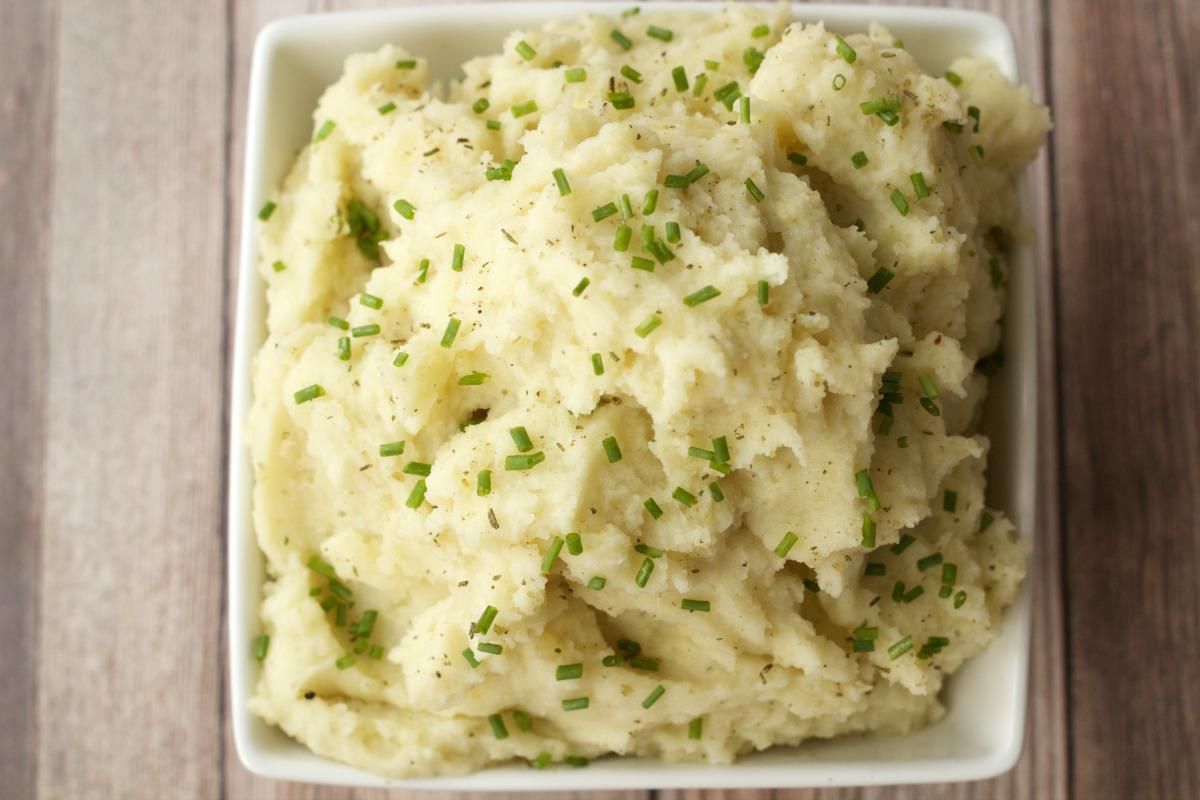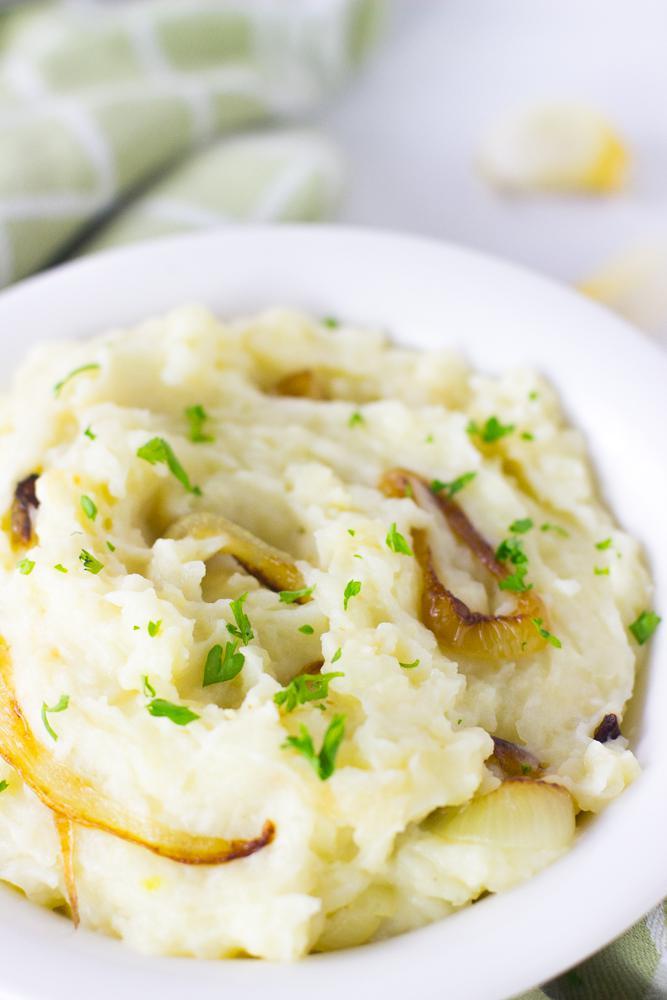The first image is the image on the left, the second image is the image on the right. Given the left and right images, does the statement "One image shows mashed potatoes with chives served in a square white bowl." hold true? Answer yes or no. Yes. 